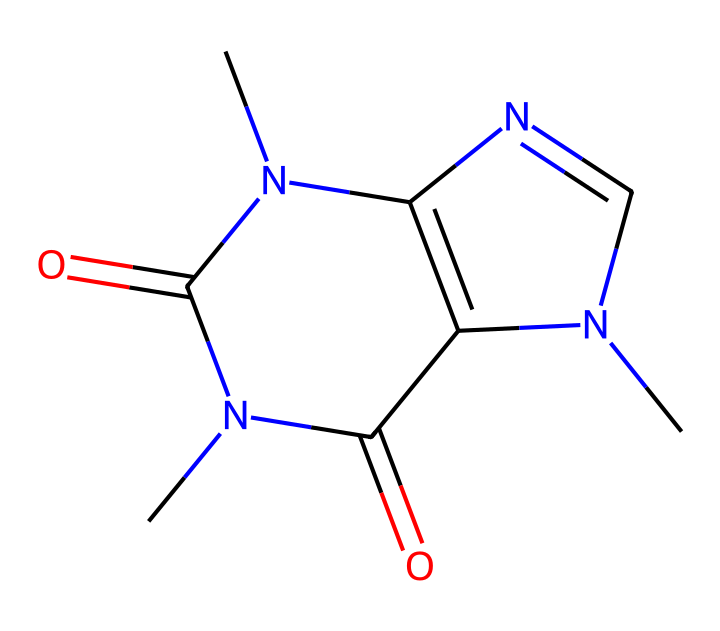What is the molecular formula of this compound? By analyzing the Chemical Structure through the SMILES representation, we can count the number of each type of atom present: carbon (C), nitrogen (N), and oxygen (O). There are 8 carbons, 10 hydrogens, 4 nitrogens, and 2 oxygens in the structure. Therefore, the molecular formula can be derived as C8H10N4O2.
Answer: C8H10N4O2 How many rings are in the structure? The SMILES notation indicates connectivity and cyclic structures. Inspecting the structure reveals that there are two fused rings, which can be visually confirmed in the arrangement of the nitrogen and carbon atoms. Thus, the structure contains two rings.
Answer: 2 What is the primary functional group present in caffeine? Identifying the prevalent functional group in the structure requires recognizing common features. In caffeine, we see two carbonyl groups (C=O), which are characteristic of ketones when accompanied by nitrogen atoms. Caffeine specifically contains a ketone functional group.
Answer: ketone What type of nitrogen atoms is present, and how many are there? Analyzing the structure, we find that there are four nitrogen atoms in total. Three of them are in the form of amine groups (connected to carbon) and one is part of a pyrimidine-like structure, classifying them accordingly.
Answer: 4 What is the connectivity of the oxygen atoms in this structure? The oxygen atoms are part of carbonyl functional groups. In the structure, both oxygen atoms are involved in double bonds with carbon atoms, suggesting they are in the form of carbonyls. This configuration indicates that they are key functional components of this molecule.
Answer: carbonyls Is this compound a saturated or unsaturated ketone? For this type of ketone, one identifies whether it has a double bond or not. Observing the presence of double bonds in the structure (through C=O and other potential carbon double bonds), we conclude that it is indeed unsaturated due to the presence of these multiple bonds.
Answer: unsaturated 